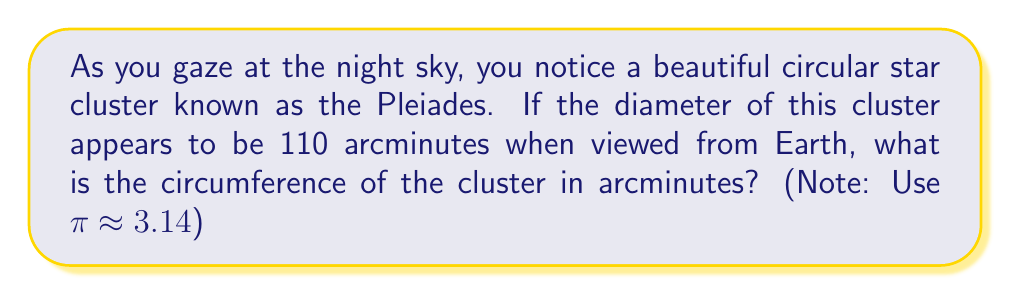Can you answer this question? Let's approach this step-by-step:

1) First, recall the formula for the circumference of a circle:

   $$C = \pi d$$

   where $C$ is the circumference and $d$ is the diameter.

2) We're given the diameter in arcminutes: $d = 110$ arcminutes.

3) Substituting this into our formula:

   $$C = \pi \cdot 110$$

4) Now, we can use the approximation $\pi \approx 3.14$:

   $$C \approx 3.14 \cdot 110$$

5) Let's calculate this:

   $$C \approx 345.4 \text{ arcminutes}$$

6) Rounding to the nearest arcminute:

   $$C \approx 345 \text{ arcminutes}$$

This means that if you were to trace the edge of the Pleiades cluster in the night sky, you would trace an arc of about 345 arcminutes.
Answer: The circumference of the Pleiades star cluster is approximately 345 arcminutes. 